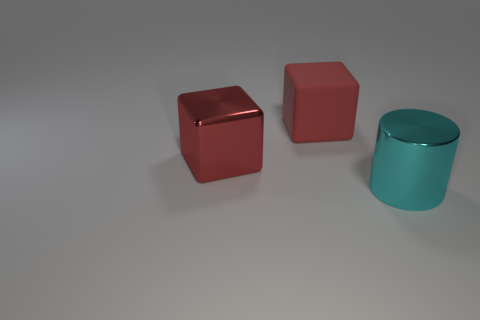Add 3 big cyan shiny objects. How many objects exist? 6 Subtract all cubes. How many objects are left? 1 Add 1 big metal cylinders. How many big metal cylinders are left? 2 Add 1 large matte cubes. How many large matte cubes exist? 2 Subtract 0 purple blocks. How many objects are left? 3 Subtract all big red objects. Subtract all small balls. How many objects are left? 1 